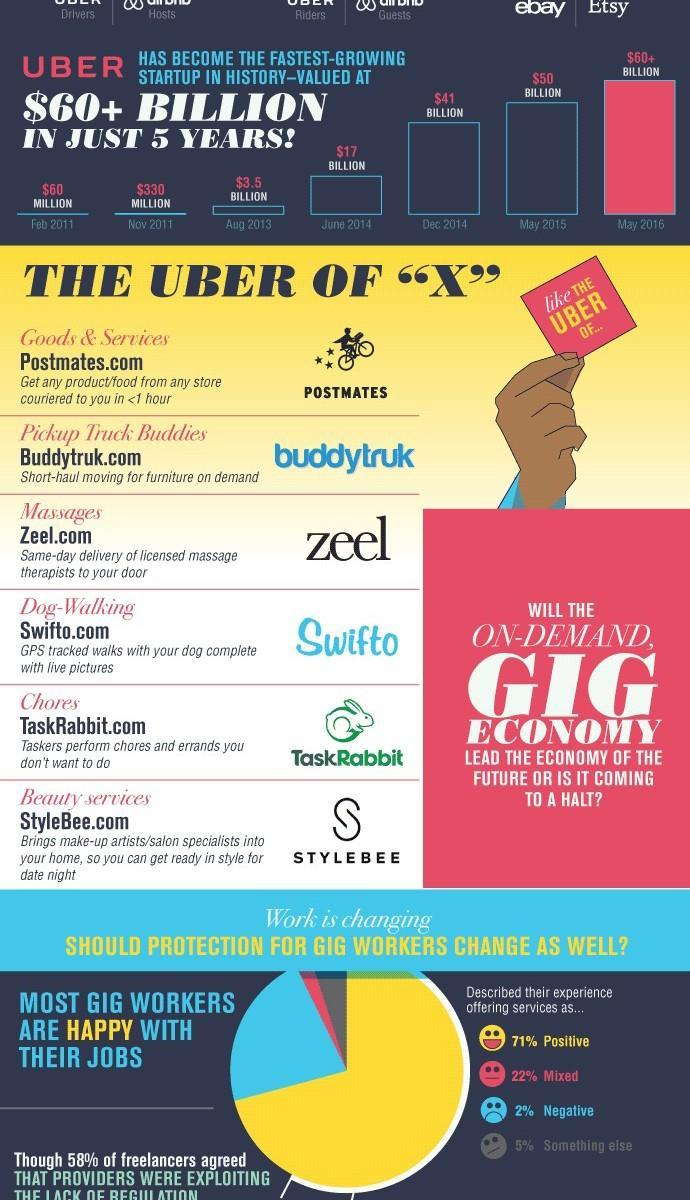WHat is written on the red note held by the hand
Answer the question with a short phrase. like THE UBER OF... WHat % of gig workers had a positive or mixed experience 93 What is written under the picture of the rabbit TaskRabbit How much in value in million in Uber grow from Feb 2011 to Nov 2011 270 